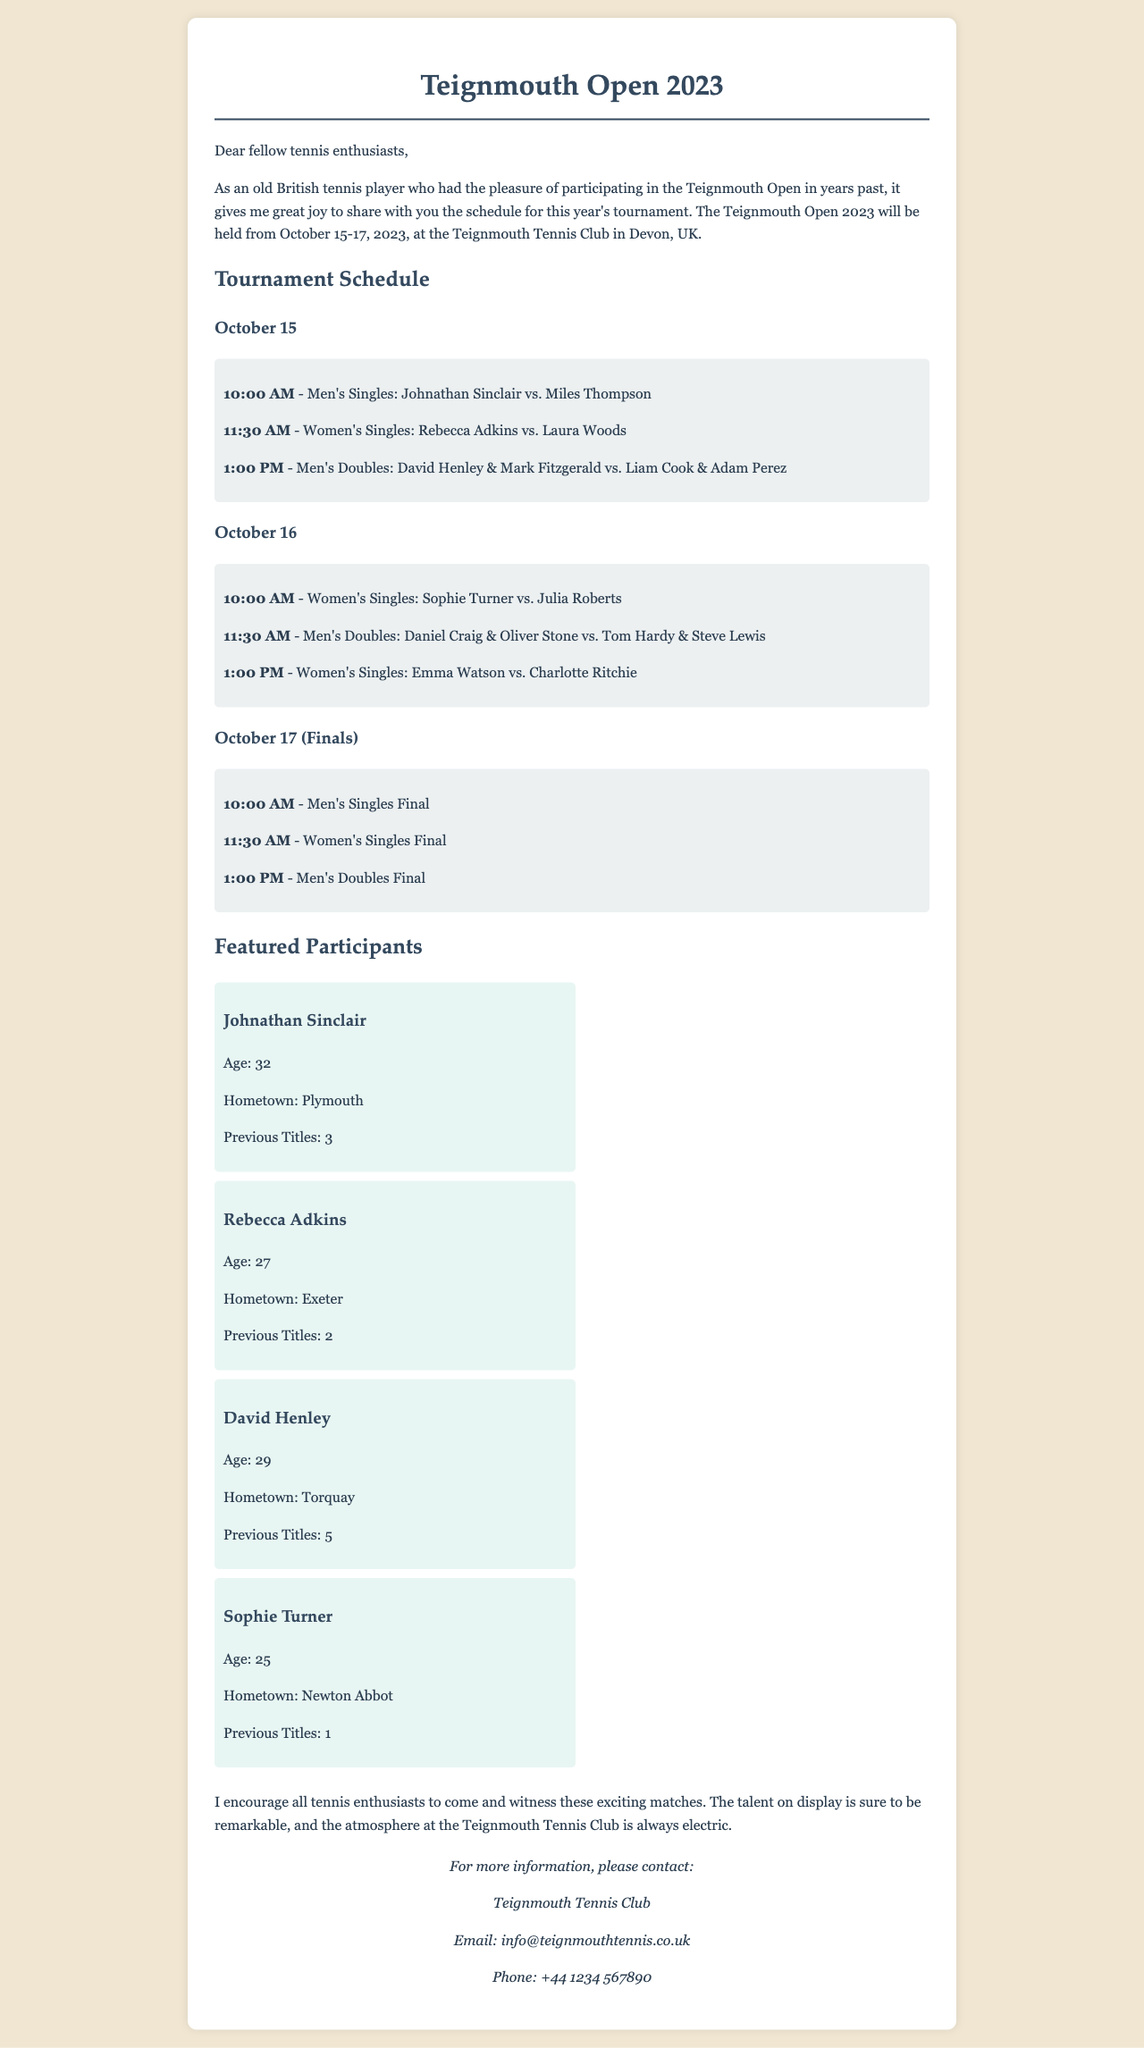What are the dates of the tournament? The tournament will be held from October 15 to October 17, 2023.
Answer: October 15-17, 2023 Who is playing in the Men's Singles match at 10:00 AM on October 15? The Men's Singles match at 10:00 AM is between Johnathan Sinclair and Miles Thompson.
Answer: Johnathan Sinclair vs. Miles Thompson What time is the Women's Singles final scheduled for? The Women's Singles final is scheduled for 11:30 AM on October 17.
Answer: 11:30 AM Which participant has the most previous titles? Among the featured participants, David Henley has the most previous titles with 5.
Answer: 5 How many matches are scheduled for October 16? There are three matches scheduled for October 16.
Answer: 3 What is the location of the tournament? The tournament will take place at the Teignmouth Tennis Club in Devon, UK.
Answer: Teignmouth Tennis Club Which participant is from Plymouth? Johnathan Sinclair is the participant from Plymouth.
Answer: Johnathan Sinclair What email address can be used for inquiries? The email address provided for inquiries is info@teignmouthtennis.co.uk.
Answer: info@teignmouthtennis.co.uk What time does the Men's Doubles match on October 15 start? The Men's Doubles match on October 15 starts at 1:00 PM.
Answer: 1:00 PM 